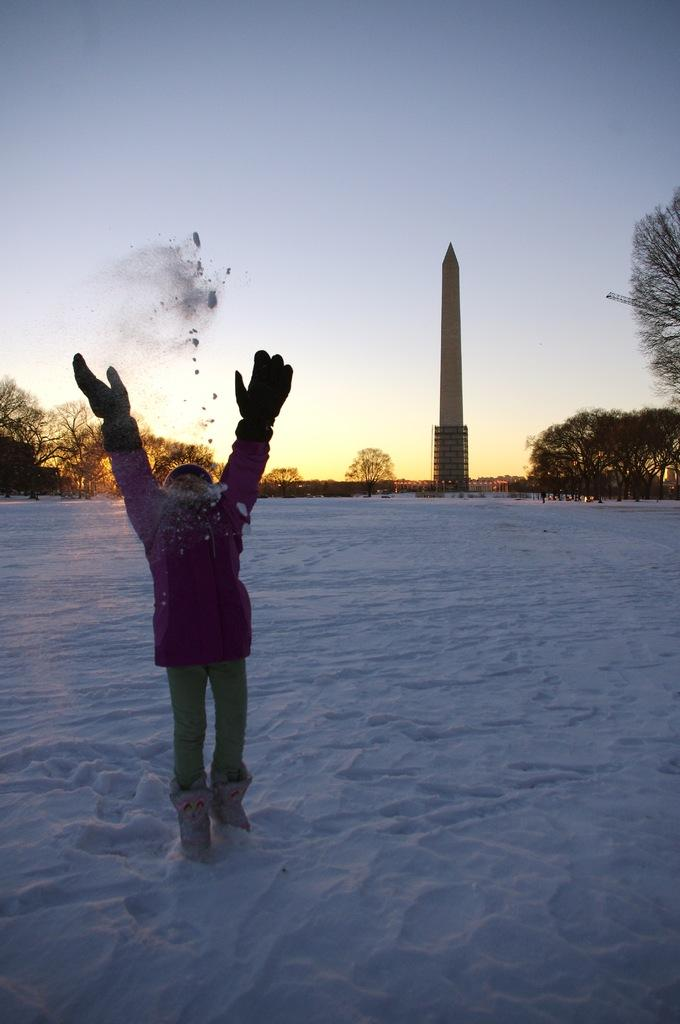What is the person in the image standing on? The person is standing on the snow. What can be seen in the background of the image? There is a tower and trees in the background of the image. What is visible in the sky in the image? The sky is visible in the background of the image. What letter is being sung by the person in the image? There is no indication in the image that the person is singing a letter or any songs. 